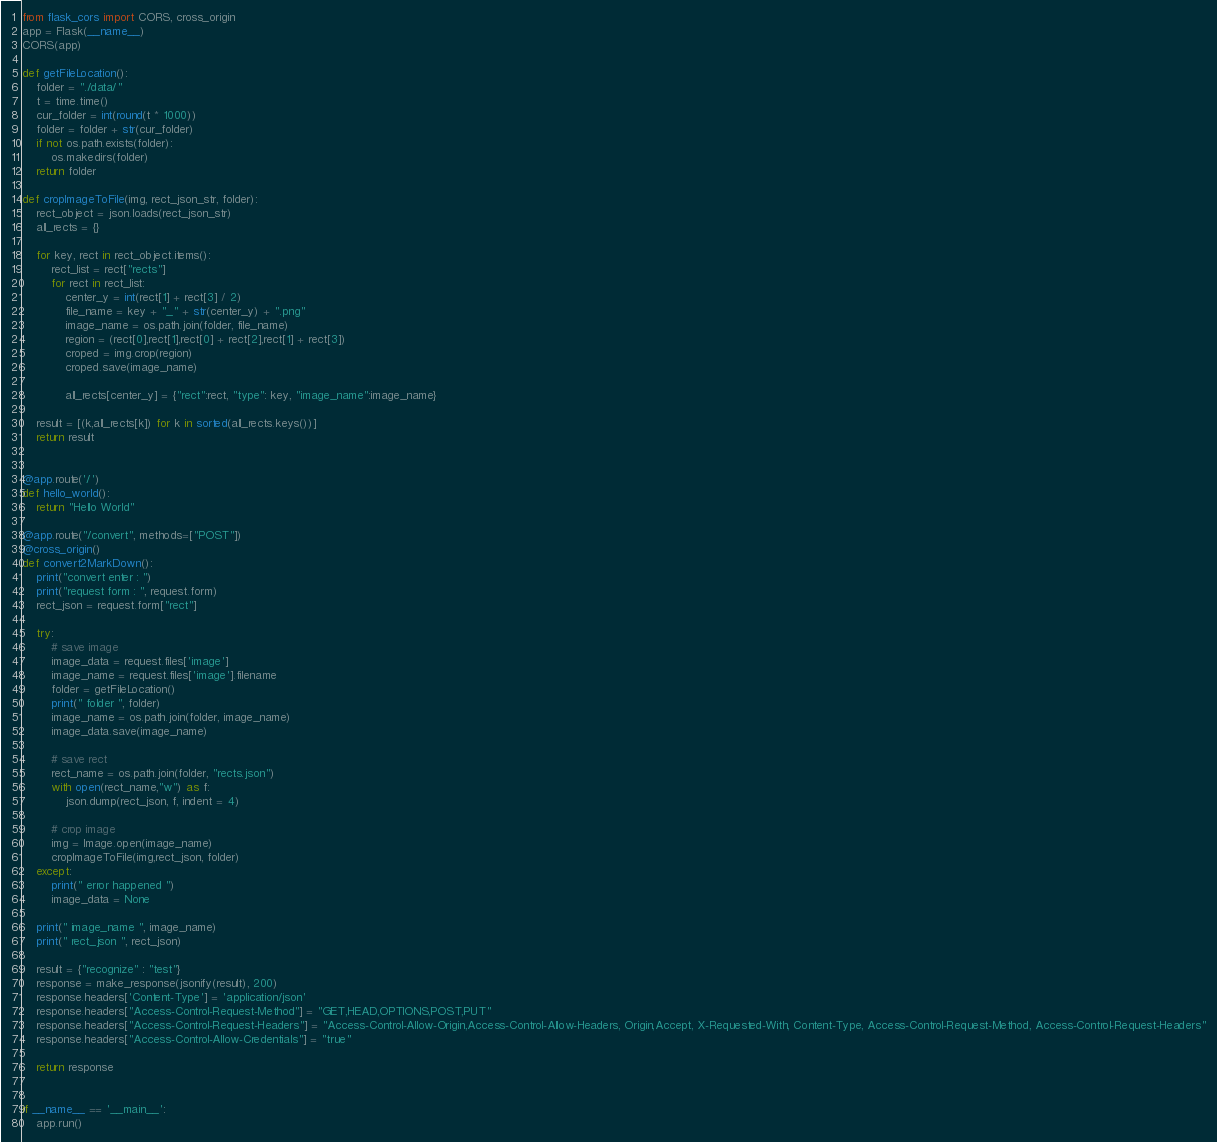Convert code to text. <code><loc_0><loc_0><loc_500><loc_500><_Python_>from flask_cors import CORS, cross_origin
app = Flask(__name__)
CORS(app)

def getFileLocation():
    folder = "./data/"
    t = time.time()
    cur_folder = int(round(t * 1000))
    folder = folder + str(cur_folder)
    if not os.path.exists(folder):
        os.makedirs(folder)
    return folder

def cropImageToFile(img, rect_json_str, folder):
    rect_object = json.loads(rect_json_str)
    all_rects = {}

    for key, rect in rect_object.items():
        rect_list = rect["rects"]
        for rect in rect_list:
            center_y = int(rect[1] + rect[3] / 2)
            file_name = key + "_" + str(center_y) + ".png"
            image_name = os.path.join(folder, file_name)
            region = (rect[0],rect[1],rect[0] + rect[2],rect[1] + rect[3])
            croped = img.crop(region)
            croped.save(image_name)

            all_rects[center_y] = {"rect":rect, "type": key, "image_name":image_name}

    result = [(k,all_rects[k]) for k in sorted(all_rects.keys())]
    return result


@app.route('/')  
def hello_world():  
    return "Hello World"  

@app.route("/convert", methods=["POST"])
@cross_origin()
def convert2MarkDown():
    print("convert enter : ")
    print("request form : ", request.form)
    rect_json = request.form["rect"]

    try:
        # save image
        image_data = request.files['image']
        image_name = request.files['image'].filename
        folder = getFileLocation()
        print(" folder ", folder)
        image_name = os.path.join(folder, image_name)
        image_data.save(image_name)

        # save rect
        rect_name = os.path.join(folder, "rects.json")
        with open(rect_name,"w") as f:
            json.dump(rect_json, f, indent = 4)
        
        # crop image
        img = Image.open(image_name)
        cropImageToFile(img,rect_json, folder)
    except:
        print(" error happened ")
        image_data = None
    
    print(" image_name ", image_name)
    print(" rect_json ", rect_json)

    result = {"recognize" : "test"}
    response = make_response(jsonify(result), 200)
    response.headers['Content-Type'] = 'application/json'
    response.headers["Access-Control-Request-Method"] = "GET,HEAD,OPTIONS,POST,PUT"
    response.headers["Access-Control-Request-Headers"] = "Access-Control-Allow-Origin,Access-Control-Allow-Headers, Origin,Accept, X-Requested-With, Content-Type, Access-Control-Request-Method, Access-Control-Request-Headers"
    response.headers["Access-Control-Allow-Credentials"] = "true"

    return response


if __name__ == '__main__':  
    app.run() 
</code> 